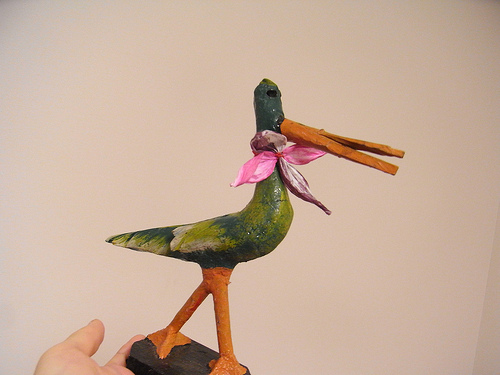<image>
Is the flower on the bird? Yes. Looking at the image, I can see the flower is positioned on top of the bird, with the bird providing support. Is there a bow on the duck? Yes. Looking at the image, I can see the bow is positioned on top of the duck, with the duck providing support. 